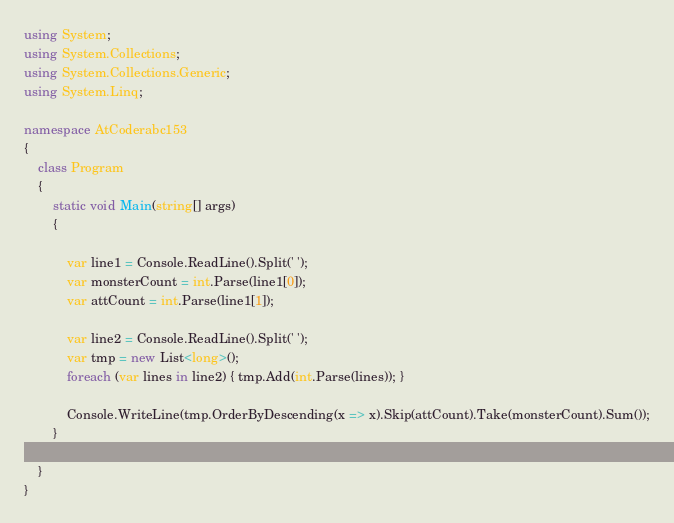Convert code to text. <code><loc_0><loc_0><loc_500><loc_500><_C#_>using System;
using System.Collections;
using System.Collections.Generic;
using System.Linq;

namespace AtCoderabc153
{
    class Program
    {
        static void Main(string[] args)
        {

            var line1 = Console.ReadLine().Split(' ');
            var monsterCount = int.Parse(line1[0]);
            var attCount = int.Parse(line1[1]);

            var line2 = Console.ReadLine().Split(' ');
            var tmp = new List<long>();
            foreach (var lines in line2) { tmp.Add(int.Parse(lines)); }

            Console.WriteLine(tmp.OrderByDescending(x => x).Skip(attCount).Take(monsterCount).Sum());
        }

    }
}

</code> 